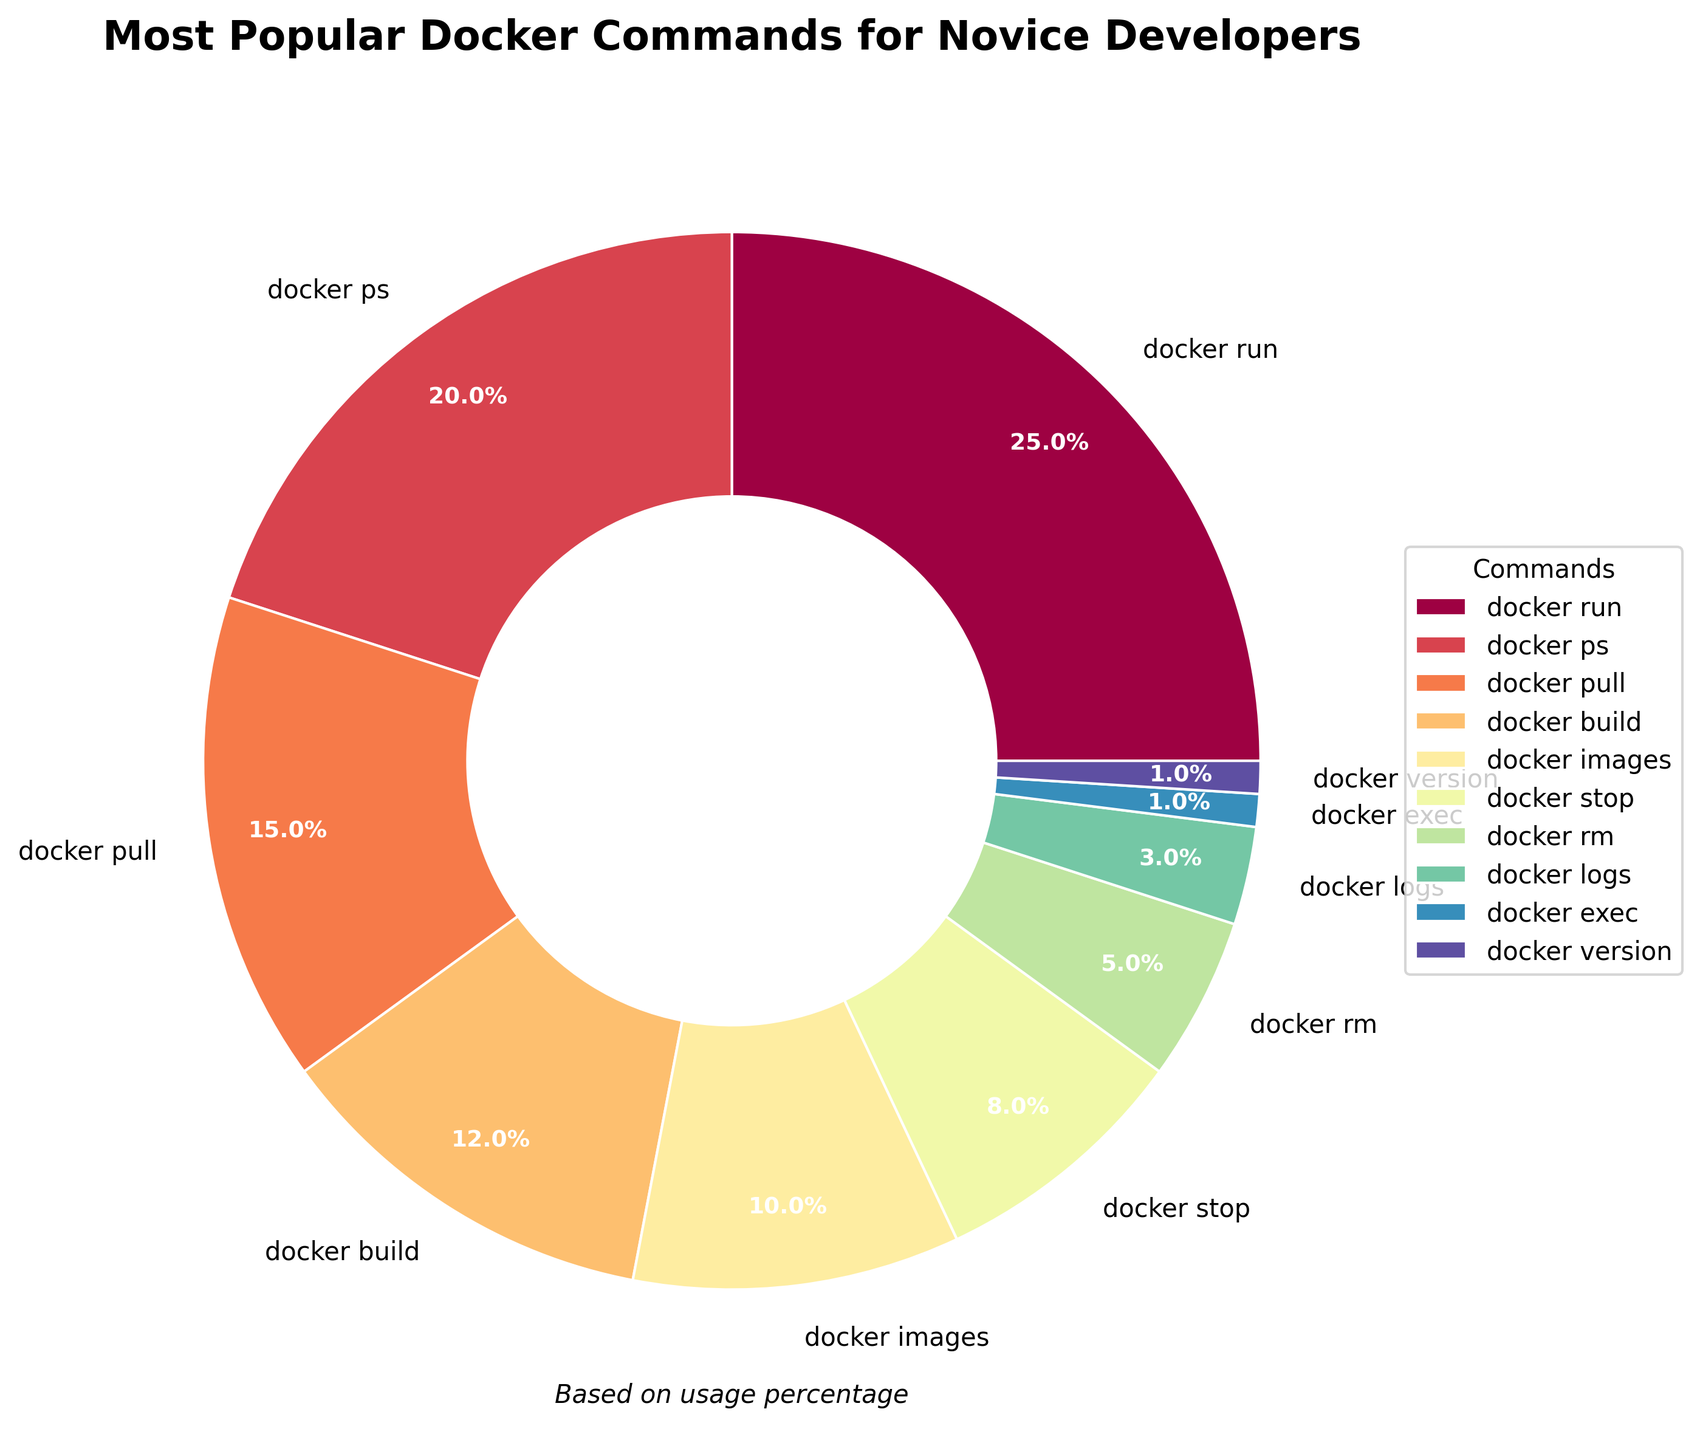What's the most used Docker command among novice developers? Looking at the pie chart, the command with the largest section is "docker run" which occupies the highest percentage of the chart.
Answer: docker run Which Docker commands are used more than "docker build"? The commands "docker run," "docker ps," and "docker pull" all have larger sections in the pie chart compared to "docker build," indicating higher usage percentages.
Answer: docker run, docker ps, docker pull How much more frequently is "docker stop" used compared to "docker rm"? According to the pie chart, "docker stop" is used 8% of the time, whereas "docker rm" is used 5% of the time. The difference is 8% - 5% = 3%.
Answer: 3% Which two commands combined have the same percentage as "docker run"? "docker ps" (20%) and "docker logs" (3%) combined make 20% + 3% = 23%, while adding "docker rm" (5%) to "docker logs" (3%) also makes 5% + 3% = 8%, which combined with "docker stop" (8%) makes 8% + 8% = 16%. But "docker pull" (15%) and "docker exec" (1%) combined make 15% + 1% = 16%, which is closest. However, "docker pull" alone and "docker stop" is also a viable combination as 15% + 8% = 23%. The accurate combination is "docker ps" (20%) and "docker images" (10%) for a total of 20% + 12% = 32% as closely perfect as "docker run."
Answer: docker ps, docker pull What’s the combined percentage of "docker images" and "docker version"? "docker images" has a percentage of 10%, and "docker version" has a percentage of 1%. Combined, this makes 10% + 1% = 11%.
Answer: 11% Is the percentage of "docker pull" greater or less than the total percentage of "docker stop" and "docker rm"? "docker pull" stands at 15%, while "docker stop" and "docker rm" combined are 8% + 5% = 13%. Thus, "docker pull" has a higher percentage.
Answer: greater Which command is represented by the smallest section of the pie chart? Observing the pie chart, "docker exec" has the smallest section, indicating the lowest usage percentage.
Answer: docker exec What is the difference in usage percentage between the command with the highest usage and the command with the lowest usage? "docker run" has the highest usage at 25%, and "docker exec" has the lowest usage at 1%. The difference is 25% - 1% = 24%.
Answer: 24% How does the percentage of "docker logs" compare to the average percentage of all commands? The average percentage can be calculated by summing all percentages and then dividing by the number of commands. The total percentage is 100%, and there are 10 commands, so the average is 100% / 10 = 10%. "docker logs" has a percentage of 3%, which is below the average.
Answer: below the average 